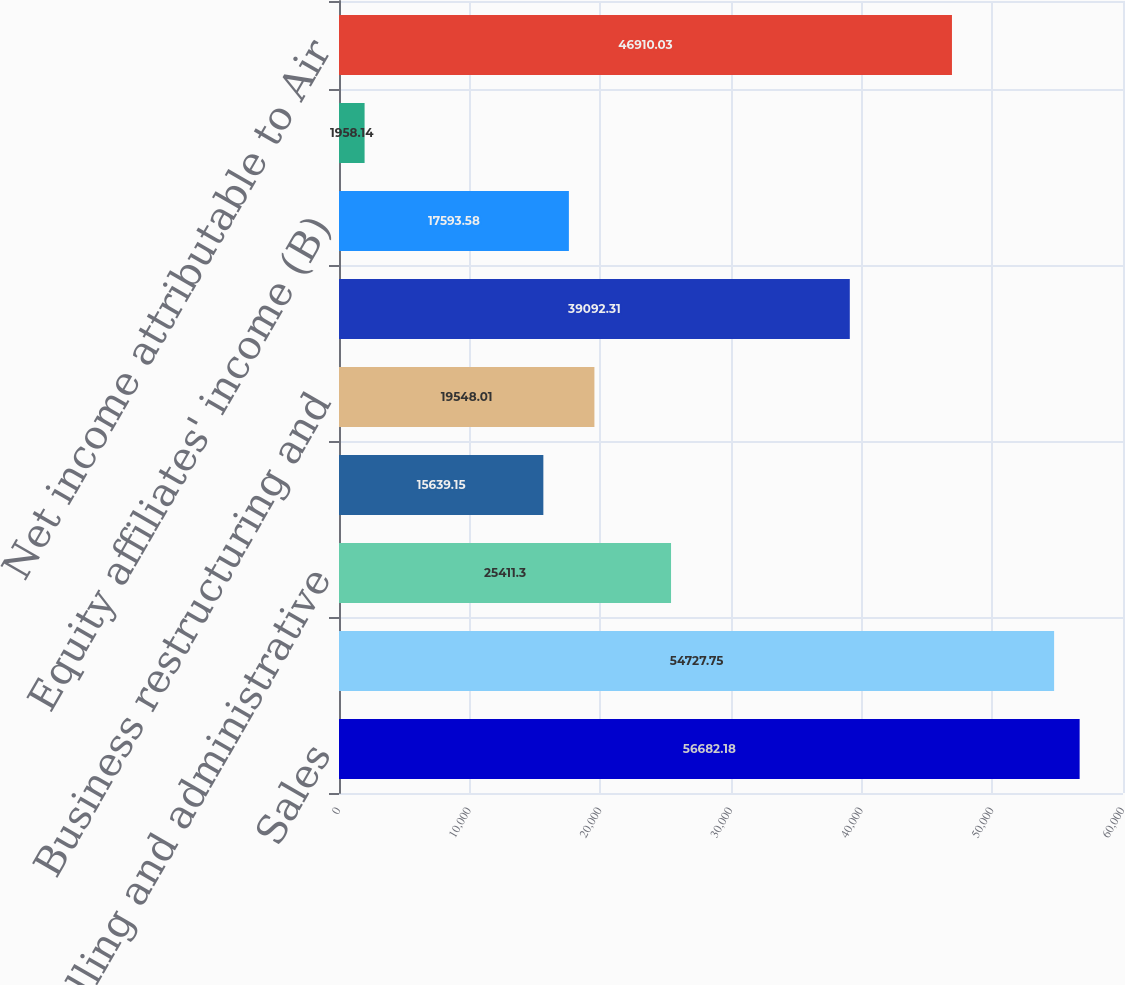Convert chart to OTSL. <chart><loc_0><loc_0><loc_500><loc_500><bar_chart><fcel>Sales<fcel>Cost of sales<fcel>Selling and administrative<fcel>Research and development<fcel>Business restructuring and<fcel>Operating income<fcel>Equity affiliates' income (B)<fcel>Income from continuing<fcel>Net income attributable to Air<nl><fcel>56682.2<fcel>54727.8<fcel>25411.3<fcel>15639.1<fcel>19548<fcel>39092.3<fcel>17593.6<fcel>1958.14<fcel>46910<nl></chart> 